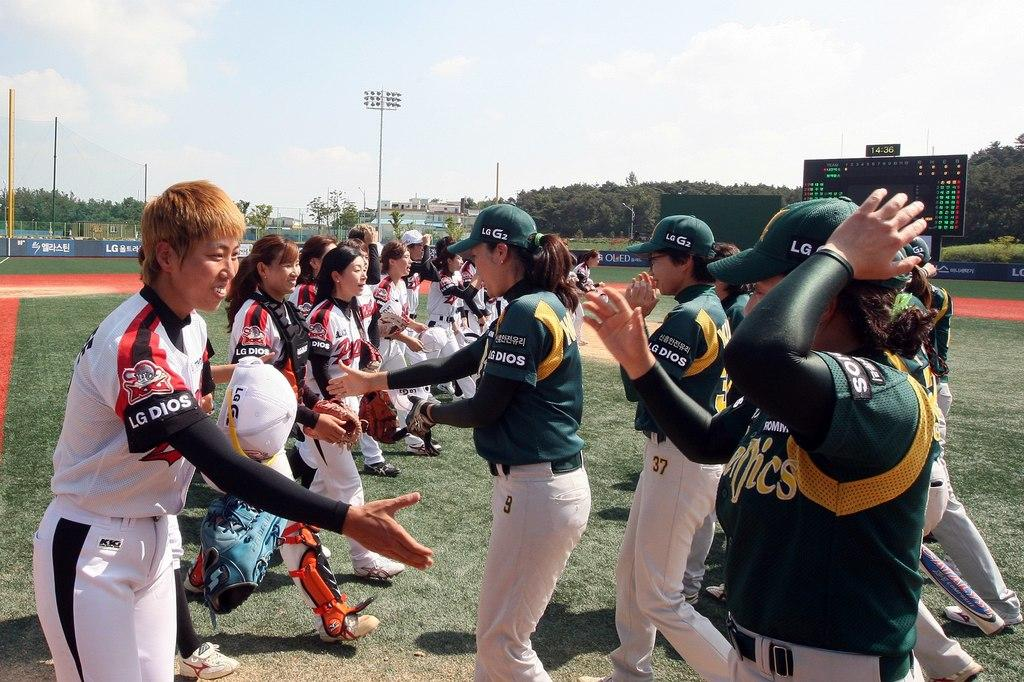<image>
Describe the image concisely. a few people on a baseball field with one wearing LG Dios on their sleeve 